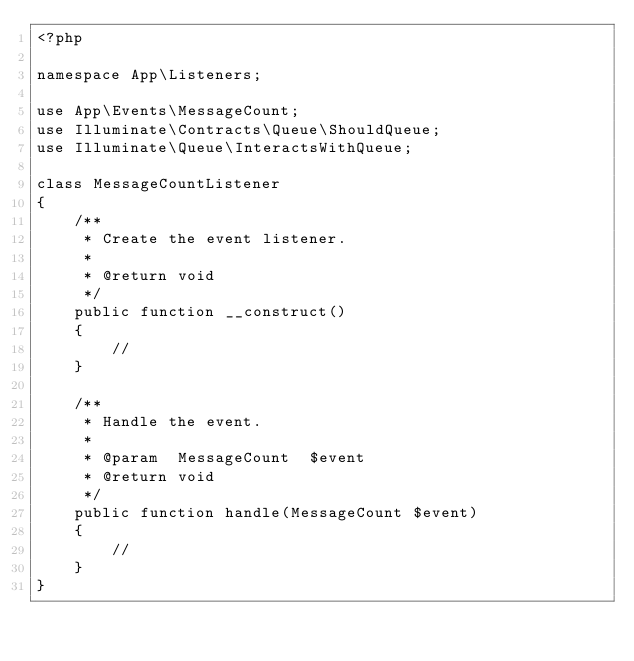<code> <loc_0><loc_0><loc_500><loc_500><_PHP_><?php

namespace App\Listeners;

use App\Events\MessageCount;
use Illuminate\Contracts\Queue\ShouldQueue;
use Illuminate\Queue\InteractsWithQueue;

class MessageCountListener
{
    /**
     * Create the event listener.
     *
     * @return void
     */
    public function __construct()
    {
        //
    }

    /**
     * Handle the event.
     *
     * @param  MessageCount  $event
     * @return void
     */
    public function handle(MessageCount $event)
    {
        //
    }
}
</code> 